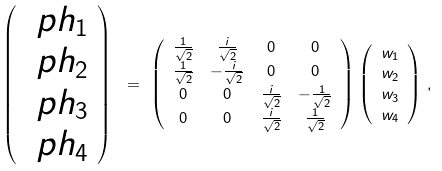<formula> <loc_0><loc_0><loc_500><loc_500>\left ( \begin{array} { c } \ p h _ { 1 } \\ \ p h _ { 2 } \\ \ p h _ { 3 } \\ \ p h _ { 4 } \end{array} \right ) \ & = \ \left ( \begin{array} { c c c c } \frac { 1 } { \sqrt { 2 } } & \frac { i } { \sqrt { 2 } } & 0 & 0 \\ \frac { 1 } { \sqrt { 2 } } & - \frac { i } { \sqrt { 2 } } & 0 & 0 \\ 0 & 0 & \frac { i } { \sqrt { 2 } } & - \frac { 1 } { \sqrt { 2 } } \\ 0 & 0 & \frac { i } { \sqrt { 2 } } & \frac { 1 } { \sqrt { 2 } } \end{array} \right ) \left ( \begin{array} { c } w _ { 1 } \\ w _ { 2 } \\ w _ { 3 } \\ w _ { 4 } \end{array} \right ) \, ,</formula> 